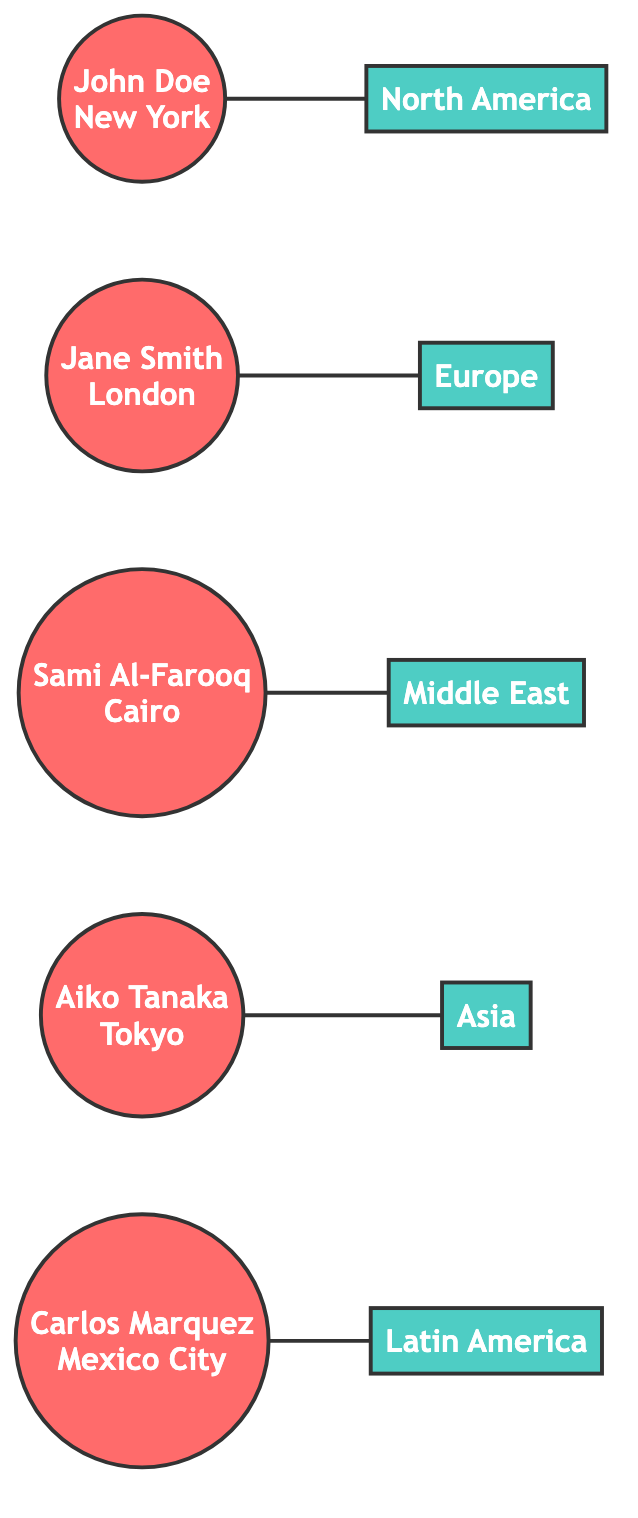What is the role of John Doe? By examining the node labeled "John_Doe," we can see that his role is indicated as "Correspondent."
Answer: Correspondent How many correspondents are there in the network? Counting the nodes labeled as correspondents, we find there are five: John Doe, Jane Smith, Sami Al-Farooq, Aiko Tanaka, and Carlos Marquez.
Answer: 5 Which correspondent covers Europe? Looking at the edge connected to the "Network_Europe," we see it is linked to the node "Jane_Smith."
Answer: Jane Smith What is the location of Aiko Tanaka? The node labeled "Aiko_Tanaka" clearly states that her location is "Tokyo."
Answer: Tokyo Which coverage area is linked to Carlos Marquez? Observing the edges, Carlos Marquez is connected to the node "Network_Latin_America."
Answer: Latin America Which correspondent is based in Cairo? From the node "Sami_Al-Farooq," we can identify that he is the correspondent based in Cairo.
Answer: Sami Al-Farooq What is the total number of edges in the graph? By counting the connections (edges) between the correspondents and their respective coverage areas, we find there are five edges.
Answer: 5 Which coverage area does John Doe represent? As we trace the connection from "John_Doe," we see that he represents "Network_North_America."
Answer: North America Are there any correspondents covering multiple regions? Each correspondent is linked to only one coverage area; hence, they do not cover multiple regions.
Answer: No 